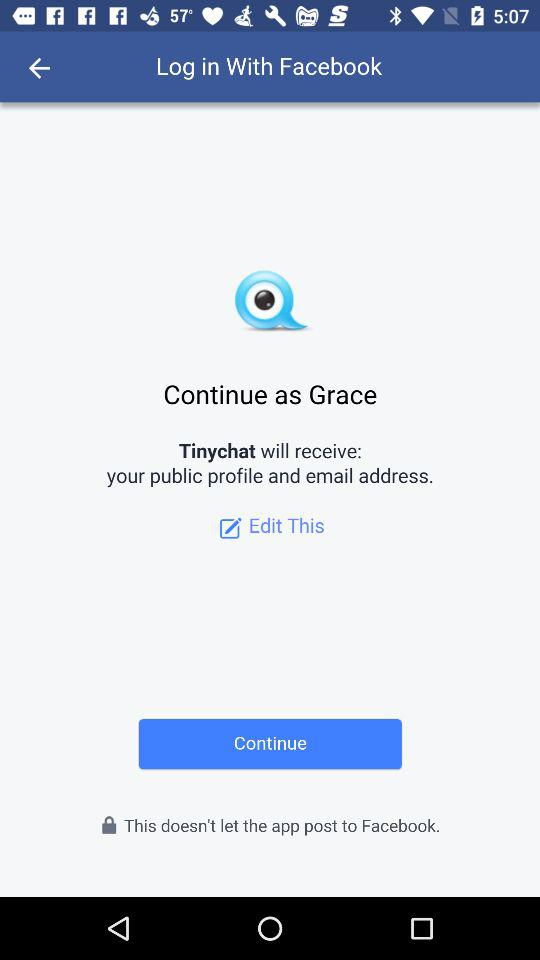What application is asking for the permission? The application asking for permission is "Tinychat". 